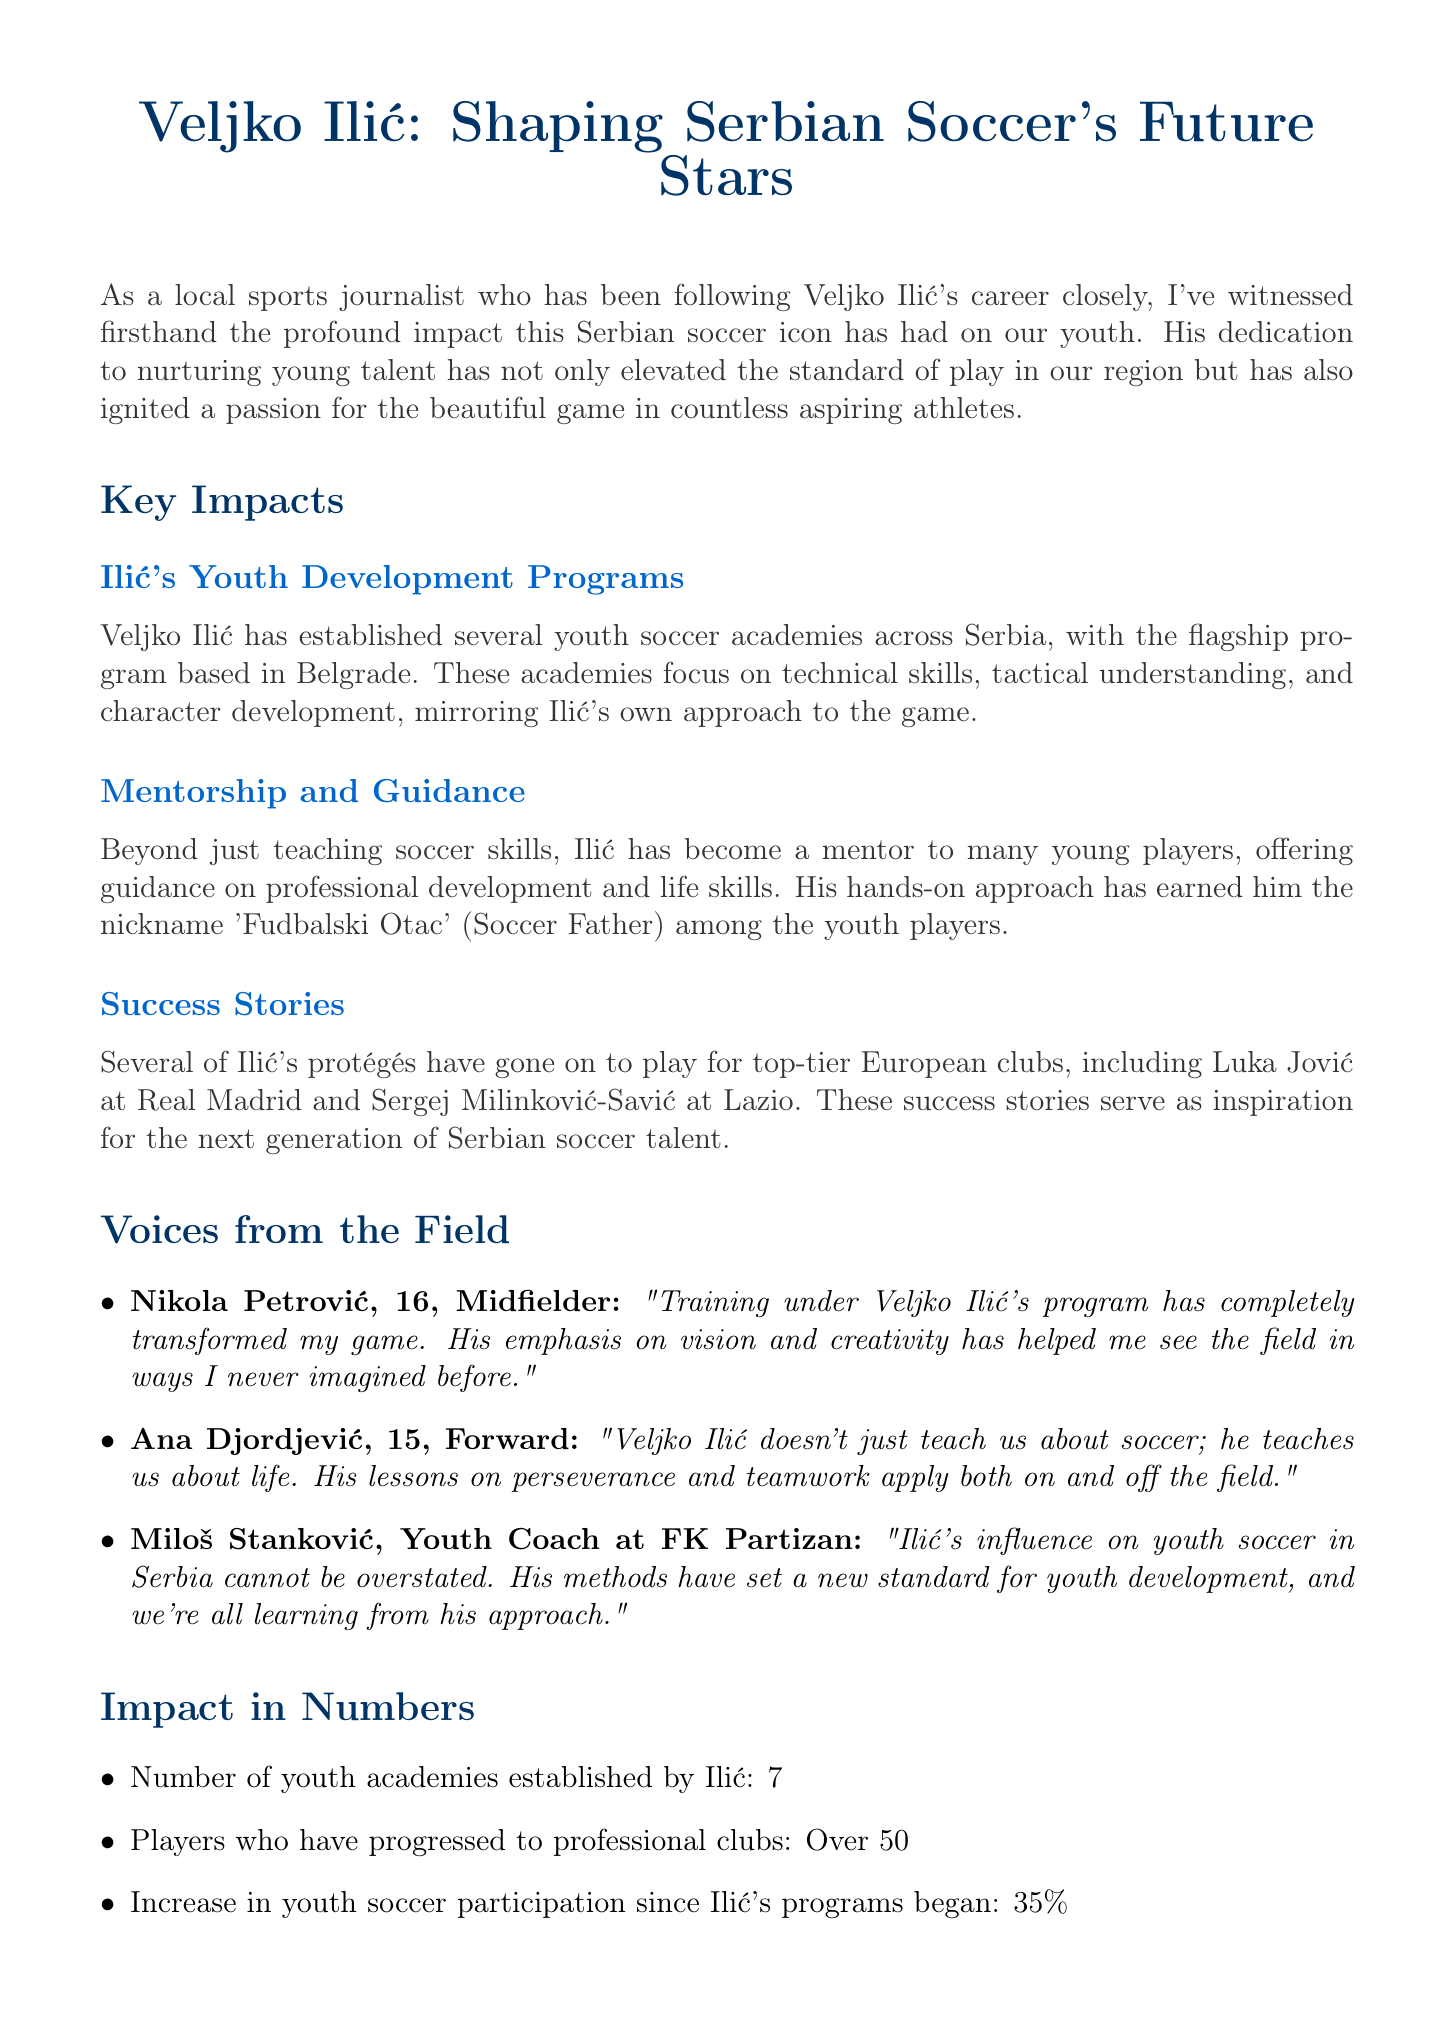What is the title of the newsletter? The title of the newsletter is stated prominently at the beginning of the document.
Answer: Veljko Ilić: Shaping Serbian Soccer's Future Stars How many youth academies has Ilić established? The document lists the number of youth academies established by Ilić in the section about impact statistics.
Answer: 7 Who is Nikola Petrović? Nikola Petrović is introduced in the interviews section, and his age and position are provided.
Answer: A 16-year-old midfielder What percentage increase in youth soccer participation is noted since Ilić's programs began? The percentage increase in youth soccer participation is provided in the impact statistics section.
Answer: 35% What is Ilić's nickname among youth players? The document mentions a specific nickname that reflects Ilić's relationship with the youth players in the mentorship section.
Answer: Fudbalski Otac Which club does Luka Jović play for? Luka Jović is mentioned in the success stories section, indicating the club he currently plays for.
Answer: Real Madrid What is the main focus of Ilić's youth academies? The document describes the primary areas of focus for Ilić's youth academies in the youth development programs section.
Answer: Technical skills, tactical understanding, and character development What future plans does Ilić have regarding youth development programs? The future plans are outlined in a specific section emphasizing Ilić's vision for expansion.
Answer: Implement training methodologies nationwide Who is quoted expressing the impact of Ilić's influence as a coach? The interviews section features a youth coach who discusses Ilić's influence on youth soccer.
Answer: Miloš Stanković 